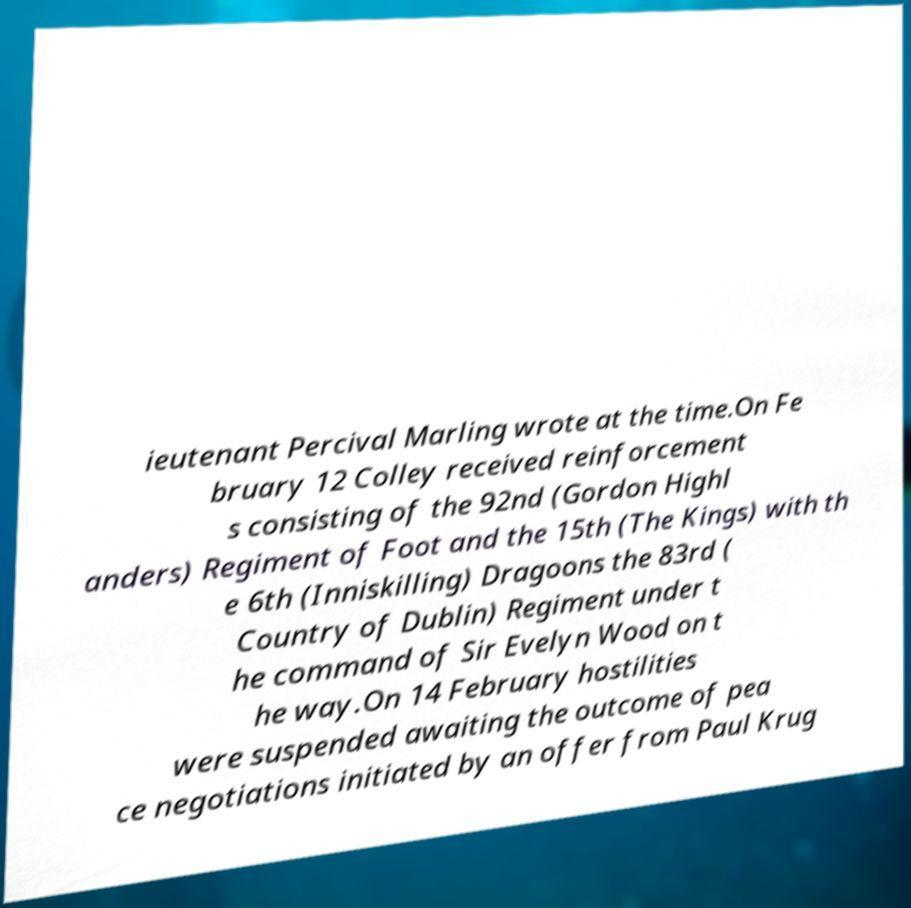For documentation purposes, I need the text within this image transcribed. Could you provide that? ieutenant Percival Marling wrote at the time.On Fe bruary 12 Colley received reinforcement s consisting of the 92nd (Gordon Highl anders) Regiment of Foot and the 15th (The Kings) with th e 6th (Inniskilling) Dragoons the 83rd ( Country of Dublin) Regiment under t he command of Sir Evelyn Wood on t he way.On 14 February hostilities were suspended awaiting the outcome of pea ce negotiations initiated by an offer from Paul Krug 